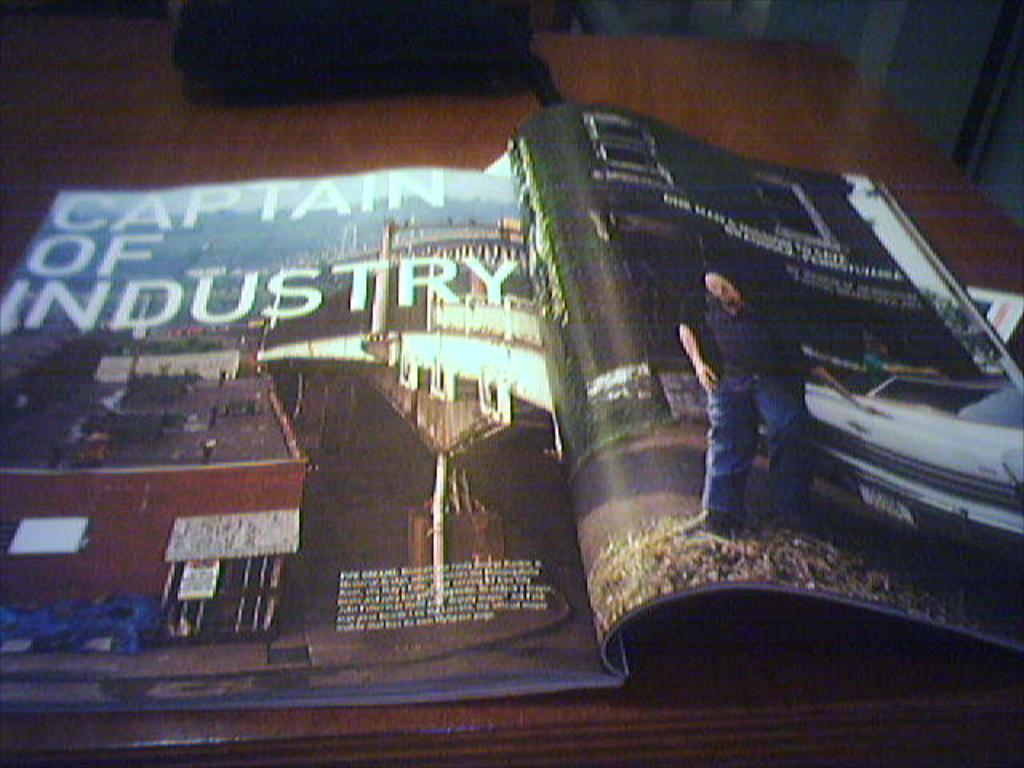What kind of leader is mentioned in the article?
Keep it short and to the point. Captain of industry. What is the article titled?
Keep it short and to the point. Captain of industry. 